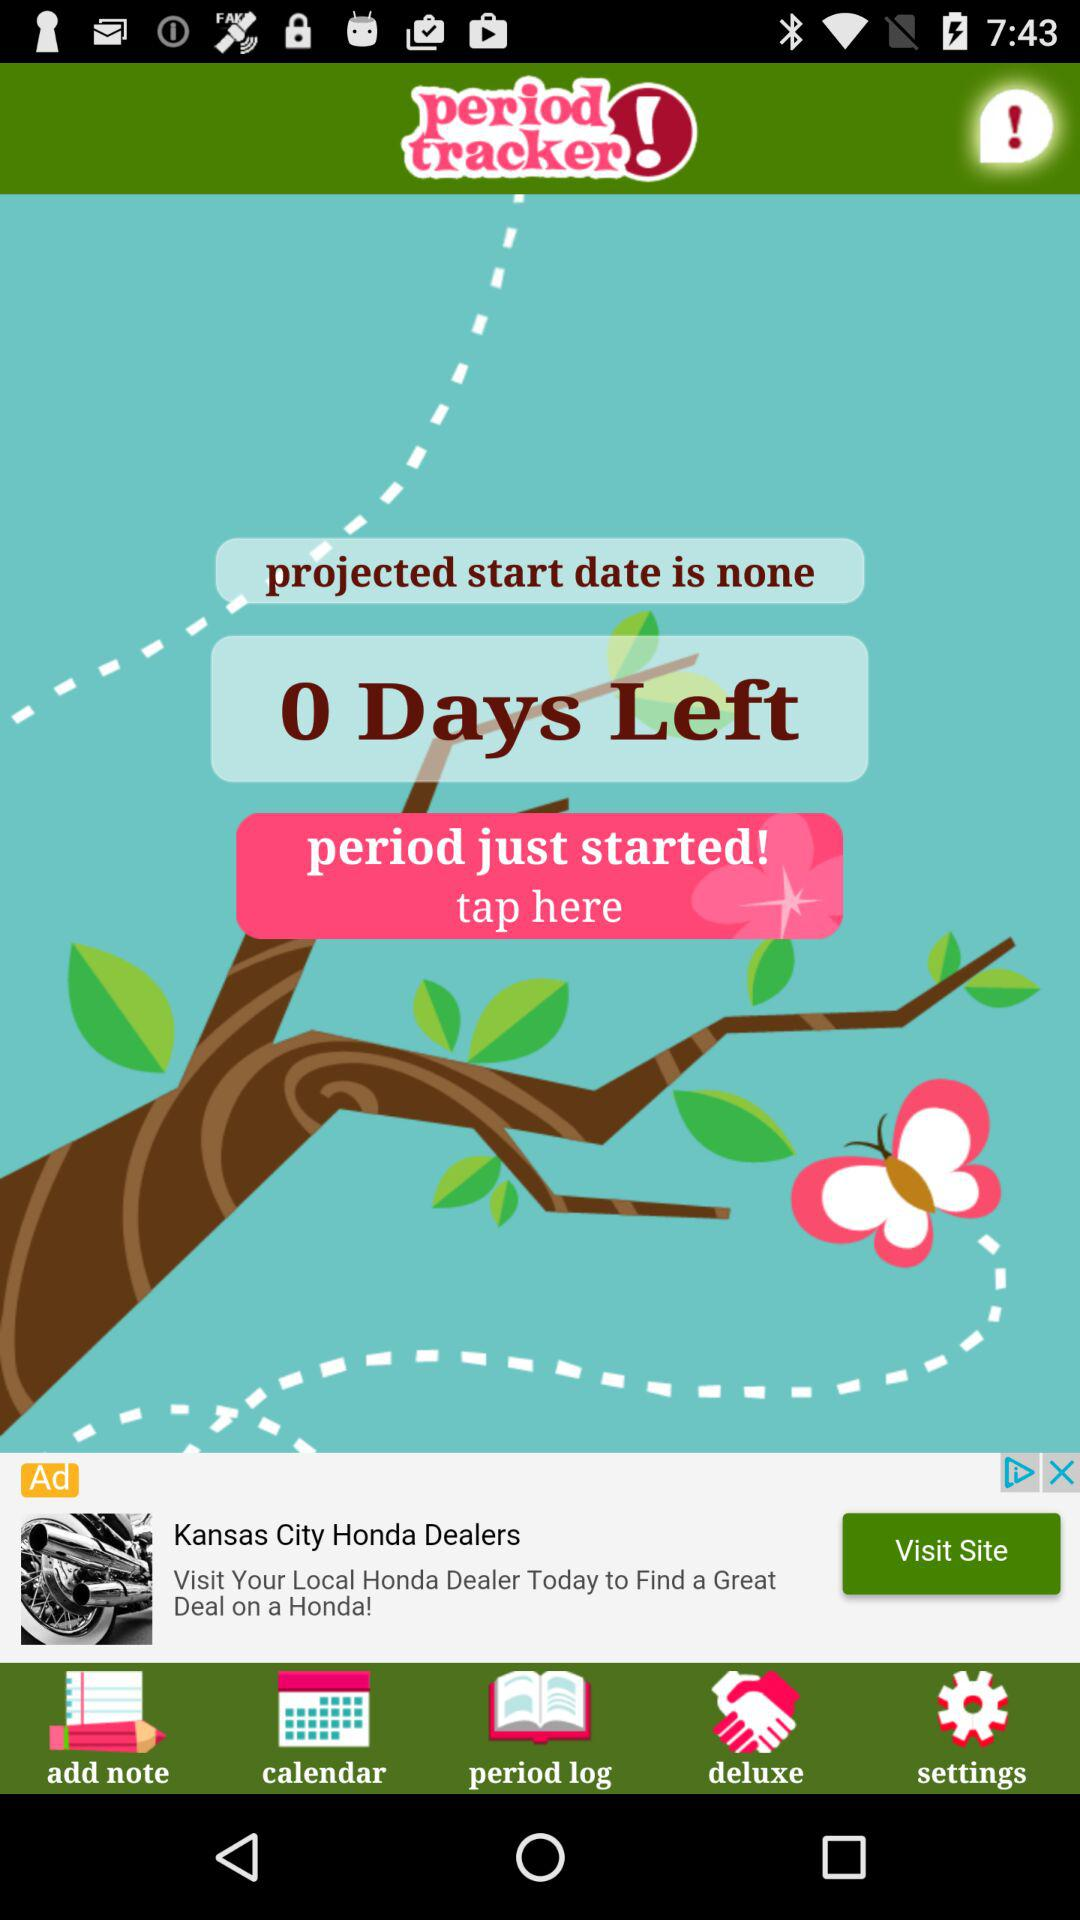How many days are left until the start of the period? Until the start of the period, 0 days are left. 